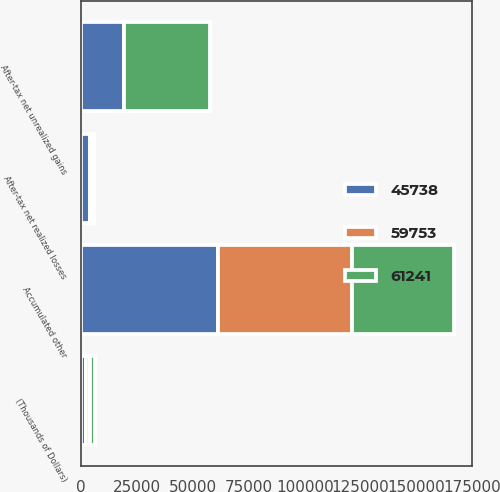<chart> <loc_0><loc_0><loc_500><loc_500><stacked_bar_chart><ecel><fcel>(Thousands of Dollars)<fcel>Accumulated other<fcel>After-tax net unrealized gains<fcel>After-tax net realized losses<nl><fcel>59753<fcel>2013<fcel>59753<fcel>12<fcel>1476<nl><fcel>45738<fcel>2012<fcel>61241<fcel>19200<fcel>3697<nl><fcel>61241<fcel>2011<fcel>45738<fcel>38292<fcel>648<nl></chart> 